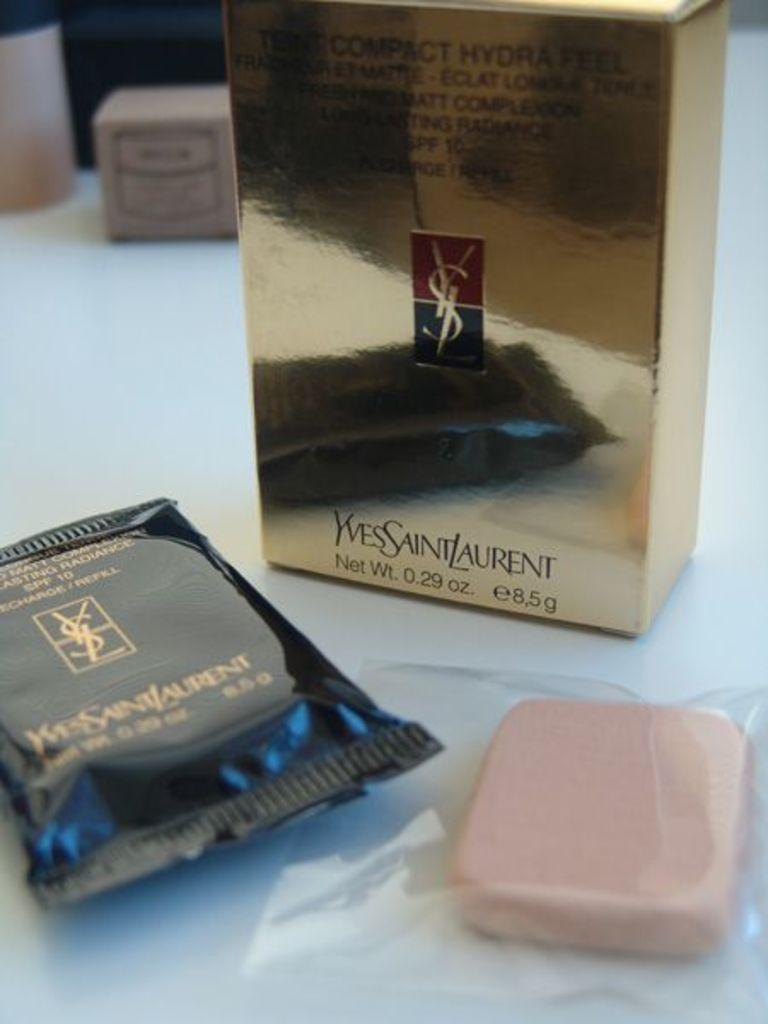<image>
Provide a brief description of the given image. a bar of soap with a box that has 8.5 on it 